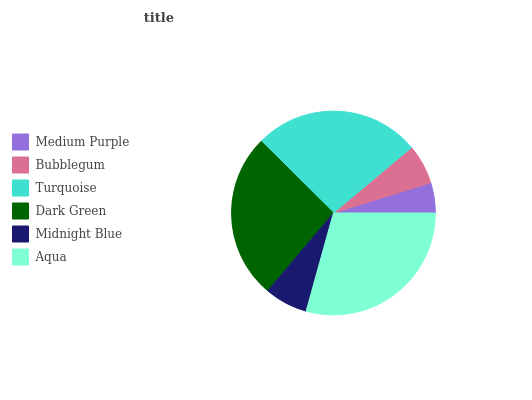Is Medium Purple the minimum?
Answer yes or no. Yes. Is Aqua the maximum?
Answer yes or no. Yes. Is Bubblegum the minimum?
Answer yes or no. No. Is Bubblegum the maximum?
Answer yes or no. No. Is Bubblegum greater than Medium Purple?
Answer yes or no. Yes. Is Medium Purple less than Bubblegum?
Answer yes or no. Yes. Is Medium Purple greater than Bubblegum?
Answer yes or no. No. Is Bubblegum less than Medium Purple?
Answer yes or no. No. Is Dark Green the high median?
Answer yes or no. Yes. Is Midnight Blue the low median?
Answer yes or no. Yes. Is Turquoise the high median?
Answer yes or no. No. Is Aqua the low median?
Answer yes or no. No. 